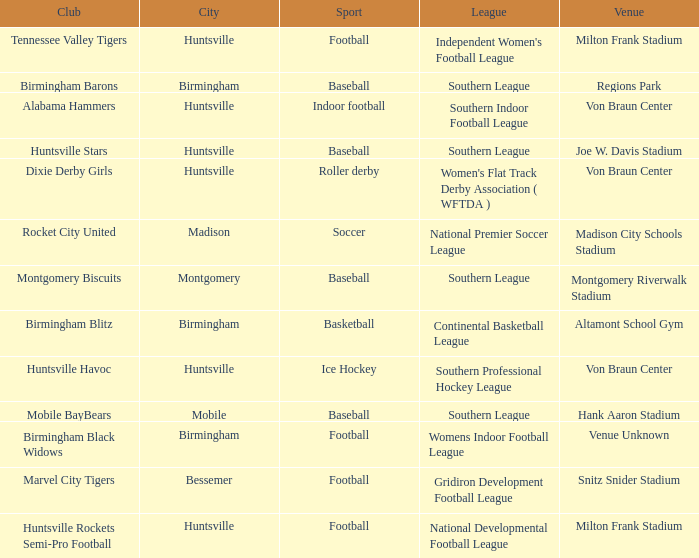Parse the table in full. {'header': ['Club', 'City', 'Sport', 'League', 'Venue'], 'rows': [['Tennessee Valley Tigers', 'Huntsville', 'Football', "Independent Women's Football League", 'Milton Frank Stadium'], ['Birmingham Barons', 'Birmingham', 'Baseball', 'Southern League', 'Regions Park'], ['Alabama Hammers', 'Huntsville', 'Indoor football', 'Southern Indoor Football League', 'Von Braun Center'], ['Huntsville Stars', 'Huntsville', 'Baseball', 'Southern League', 'Joe W. Davis Stadium'], ['Dixie Derby Girls', 'Huntsville', 'Roller derby', "Women's Flat Track Derby Association ( WFTDA )", 'Von Braun Center'], ['Rocket City United', 'Madison', 'Soccer', 'National Premier Soccer League', 'Madison City Schools Stadium'], ['Montgomery Biscuits', 'Montgomery', 'Baseball', 'Southern League', 'Montgomery Riverwalk Stadium'], ['Birmingham Blitz', 'Birmingham', 'Basketball', 'Continental Basketball League', 'Altamont School Gym'], ['Huntsville Havoc', 'Huntsville', 'Ice Hockey', 'Southern Professional Hockey League', 'Von Braun Center'], ['Mobile BayBears', 'Mobile', 'Baseball', 'Southern League', 'Hank Aaron Stadium'], ['Birmingham Black Widows', 'Birmingham', 'Football', 'Womens Indoor Football League', 'Venue Unknown'], ['Marvel City Tigers', 'Bessemer', 'Football', 'Gridiron Development Football League', 'Snitz Snider Stadium'], ['Huntsville Rockets Semi-Pro Football', 'Huntsville', 'Football', 'National Developmental Football League', 'Milton Frank Stadium']]} Which venue hosted the Gridiron Development Football League? Snitz Snider Stadium. 